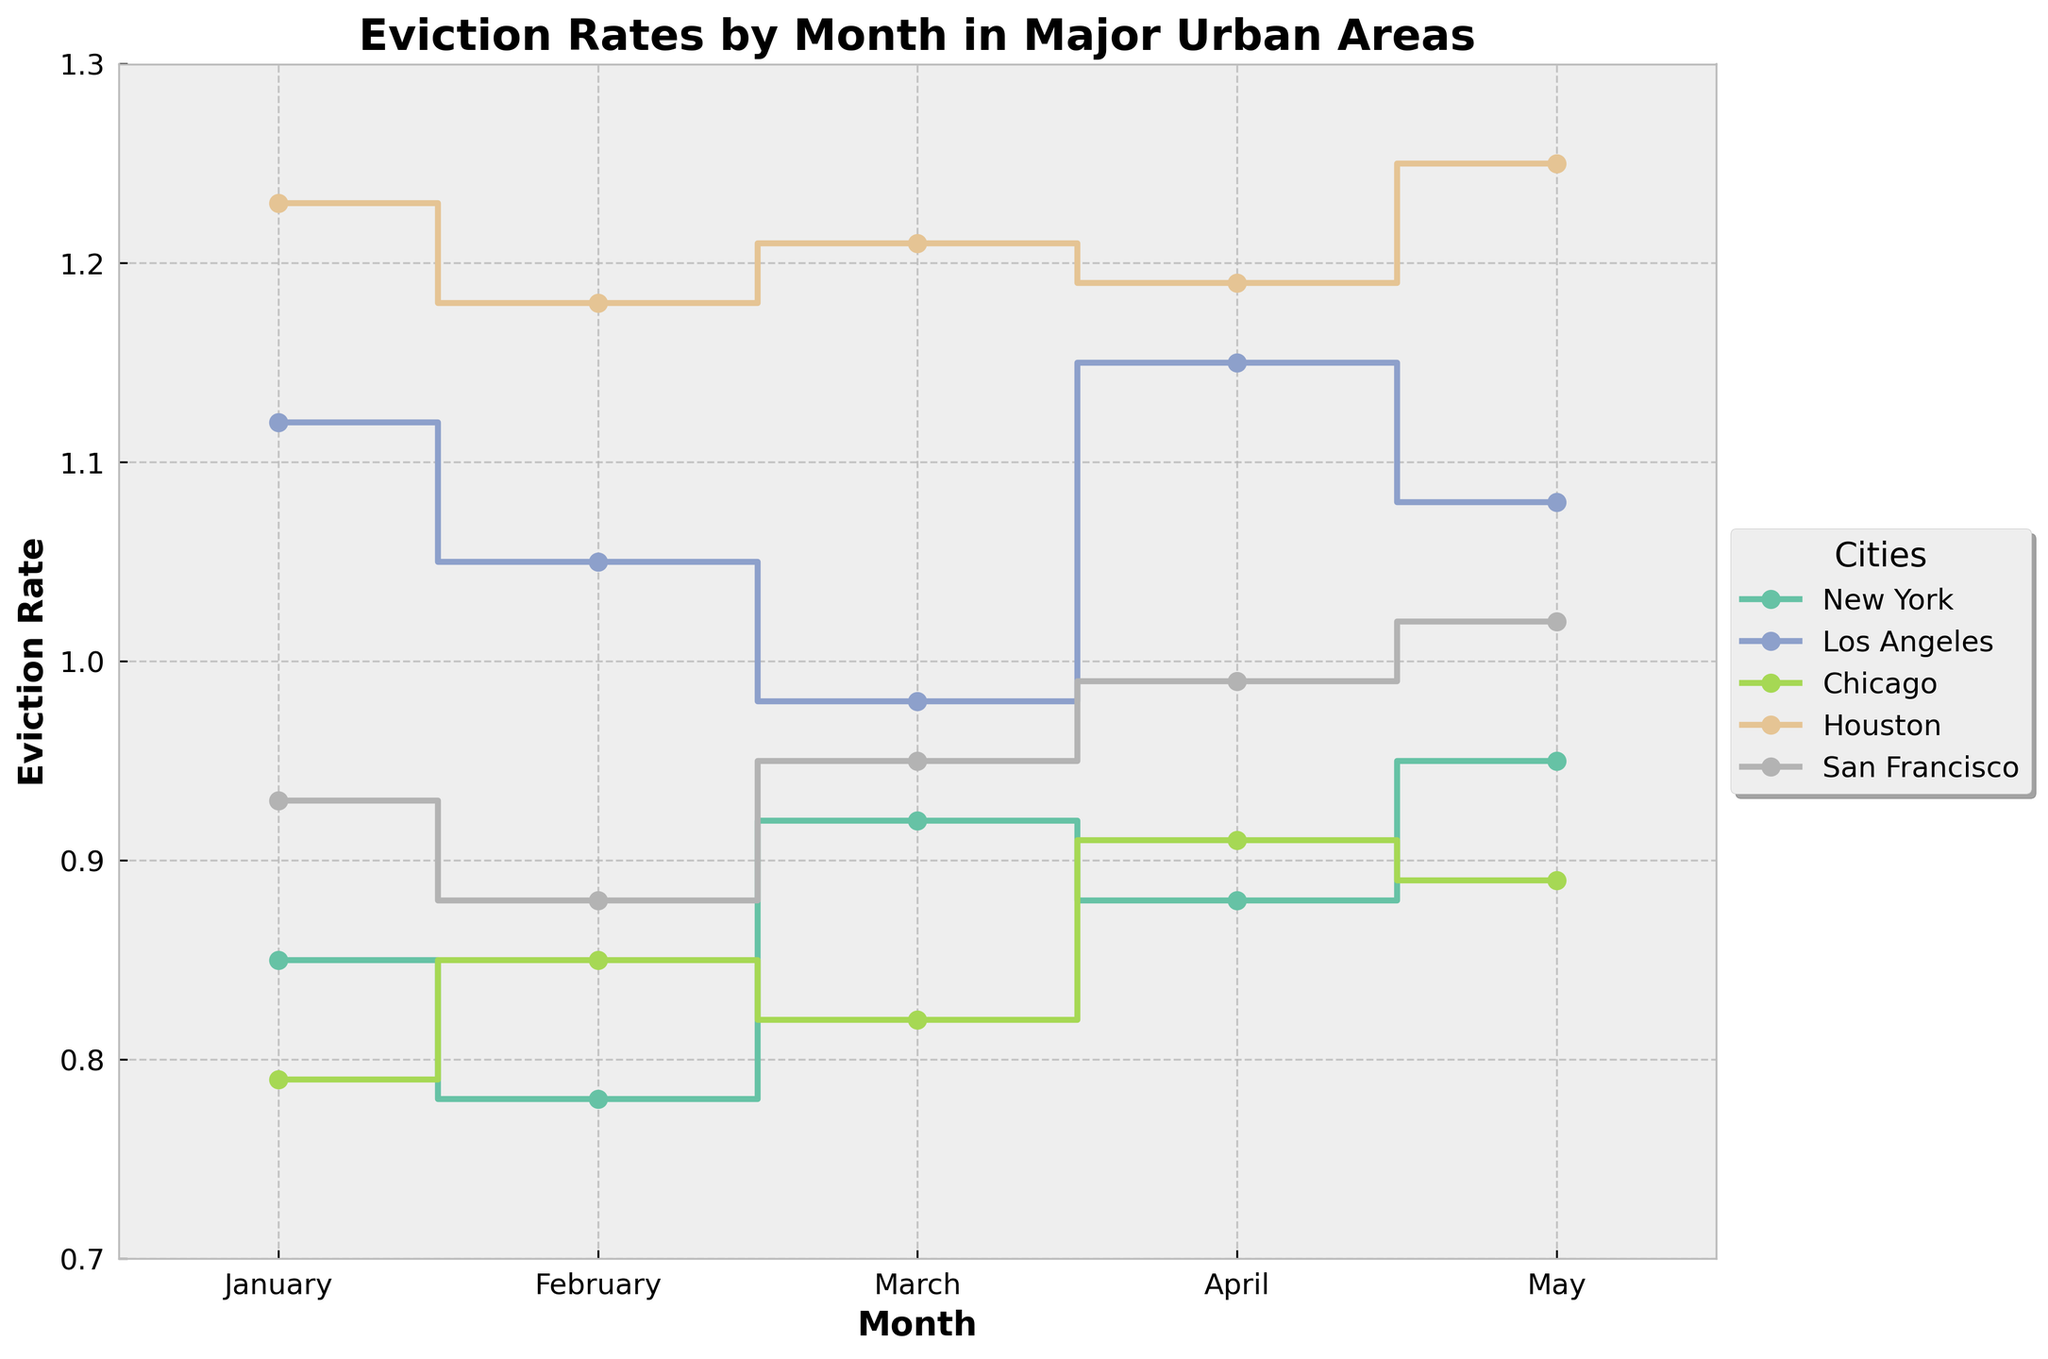What's the title of the plot? The title is located at the top center of the plot. It reads "Eviction Rates by Month in Major Urban Areas".
Answer: Eviction Rates by Month in Major Urban Areas Which city had the highest eviction rate in January? Referring to the January data points on the stair plot, the highest rate is for Houston at 1.23.
Answer: Houston What is the general trend of the eviction rates for Los Angeles over the months? Los Angeles' eviction rates are shown to start high in January, with a slight decrease in February, followed by another decrease in March. They then increase again in April and slightly decrease in May.
Answer: Initial decrease, then increase Compare the eviction rates in March between New York and Chicago. Which city had a higher rate? By looking at the plot, New York's eviction rate in March is 0.92 whereas Chicago's is 0.82. Therefore, New York had a higher rate.
Answer: New York Which city experienced the lowest eviction rate overall within these months? To find the city with the lowest rate overall, we check all values for each city, finding that Chicago in January had the lowest rate at 0.79.
Answer: Chicago Calculate the average eviction rate for New York over the five months. Summing up the rates for New York (0.85 + 0.78 + 0.92 + 0.88 + 0.95) gives 4.38. Dividing by 5 results in an average rate of 0.876.
Answer: 0.876 Which city shows the most fluctuation in eviction rates over the five months? Measuring fluctuation involves assessing the range of values for each city. Houston's eviction rate ranges from 1.18 to 1.25, a smaller range compared to others. Los Angeles shows more variation, ranging from 0.98 to 1.15.
Answer: Los Angeles Is there a month where all cities have relatively high eviction rates? High eviction rates are relative but observing April, several cities like Los Angeles (1.15), Houston (1.19), and San Francisco (0.99) all show higher rates.
Answer: April What are the colors used to represent San Francisco and Chicago in the plot? San Francisco and Chicago are identified by different colors in the legend. San Francisco typically uses a distinctive color different from Chicago to avoid confusion.
Answer: Depends on the color legend 